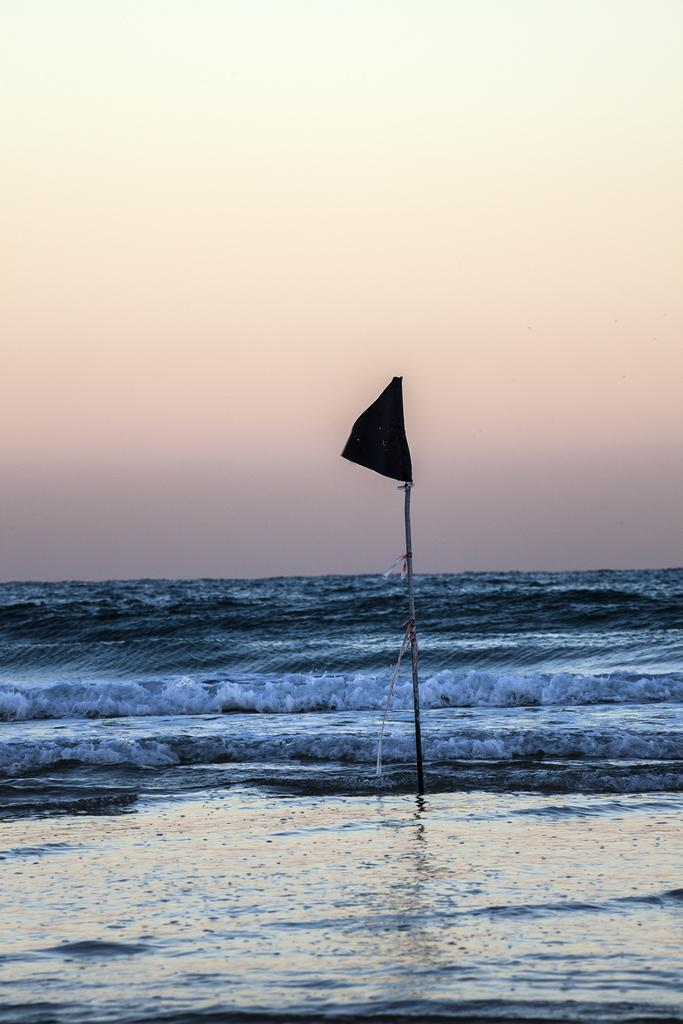What is located in the water in the image? There is a flag in the water in the image. What can be seen in the background of the image? There is a sky visible in the background of the image. Where is the tent located in the image? There is no tent present in the image. What type of fowl can be seen swimming near the flag in the water? There are no fowl visible in the image; only the flag in the water and the sky in the background are present. 